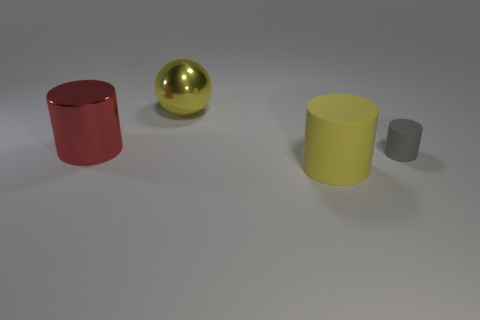There is a large cylinder that is the same color as the shiny sphere; what is its material?
Provide a succinct answer. Rubber. Are there fewer tiny cyan objects than small gray things?
Offer a very short reply. Yes. What color is the other big rubber thing that is the same shape as the gray thing?
Ensure brevity in your answer.  Yellow. There is a big yellow thing that is on the left side of the matte cylinder to the left of the small gray rubber cylinder; is there a large red thing that is right of it?
Make the answer very short. No. Does the gray object have the same shape as the big rubber object?
Ensure brevity in your answer.  Yes. Is the number of big metallic things on the right side of the big metal cylinder less than the number of blue blocks?
Give a very brief answer. No. What color is the shiny thing that is in front of the large yellow thing left of the matte cylinder that is in front of the tiny gray rubber cylinder?
Your answer should be very brief. Red. How many shiny objects are big red objects or large green cylinders?
Provide a succinct answer. 1. Does the red cylinder have the same size as the gray object?
Provide a succinct answer. No. Is the number of yellow matte cylinders on the left side of the small cylinder less than the number of big yellow metal balls behind the red cylinder?
Ensure brevity in your answer.  No. 